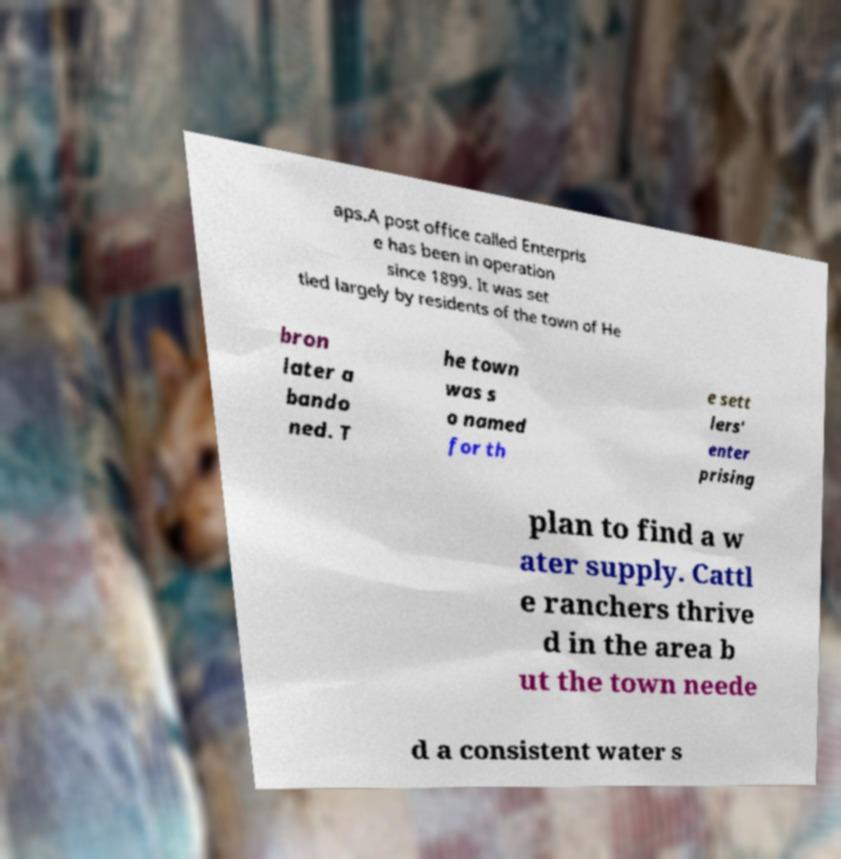Please identify and transcribe the text found in this image. aps.A post office called Enterpris e has been in operation since 1899. It was set tled largely by residents of the town of He bron later a bando ned. T he town was s o named for th e sett lers' enter prising plan to find a w ater supply. Cattl e ranchers thrive d in the area b ut the town neede d a consistent water s 